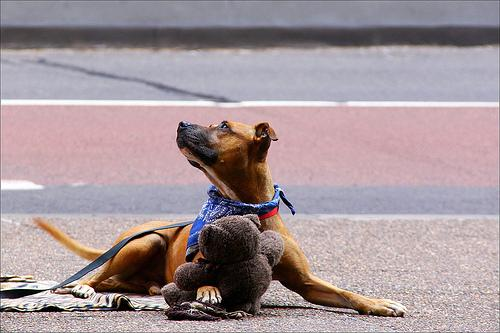State which tasks can be applied to this image: VQA, object detection, or image sentiment analysis. VQA, object detection, and image sentiment analysis tasks can all be applied to this image. Count the number of objects in the image, and describe them. There are 10 objects: the dog's head, eye, ear, paws, nose, collar, leash, the brown stuffed animal, part of the ground, and kites flying in the sky. Describe the dog's appearance and what it interacts with in the image. The dog has a black nose, is looking left, and is wearing a red collar. It interacts with a brown teddy bear. Explain the role of the paws in the image in relation to the teddy bear. One paw of the dog is holding down the leg of the teddy bear, while the other paws are in contact with the ground. Describe the sentiment of the image. The image has a joyful and playful sentiment, as the dog is playing with the teddy bear. Identify the color of the dog's collar and the stuffed animal. The collar is red, and the stuffed animal is brown. Which objects can be found in the image in multiple different sizes and positions? The paws of the dog, the element of the ground, and the kites flying in the sky are found in multiple sizes and positions. State two features of the dog's head, and a feature of the teddy bear. The dog's head has a black nose and an ear. The teddy bear is grey. Mention the primary object in the image and its actions. A dog holding a teddy bear is the main object, with the dog's paw holding down the teddy bear's leg. What type of scene is shown in the image, and what objects are present? The scene shows a dog playing with a teddy bear, with kites flying in the sky above people, and part of the ground visible. 